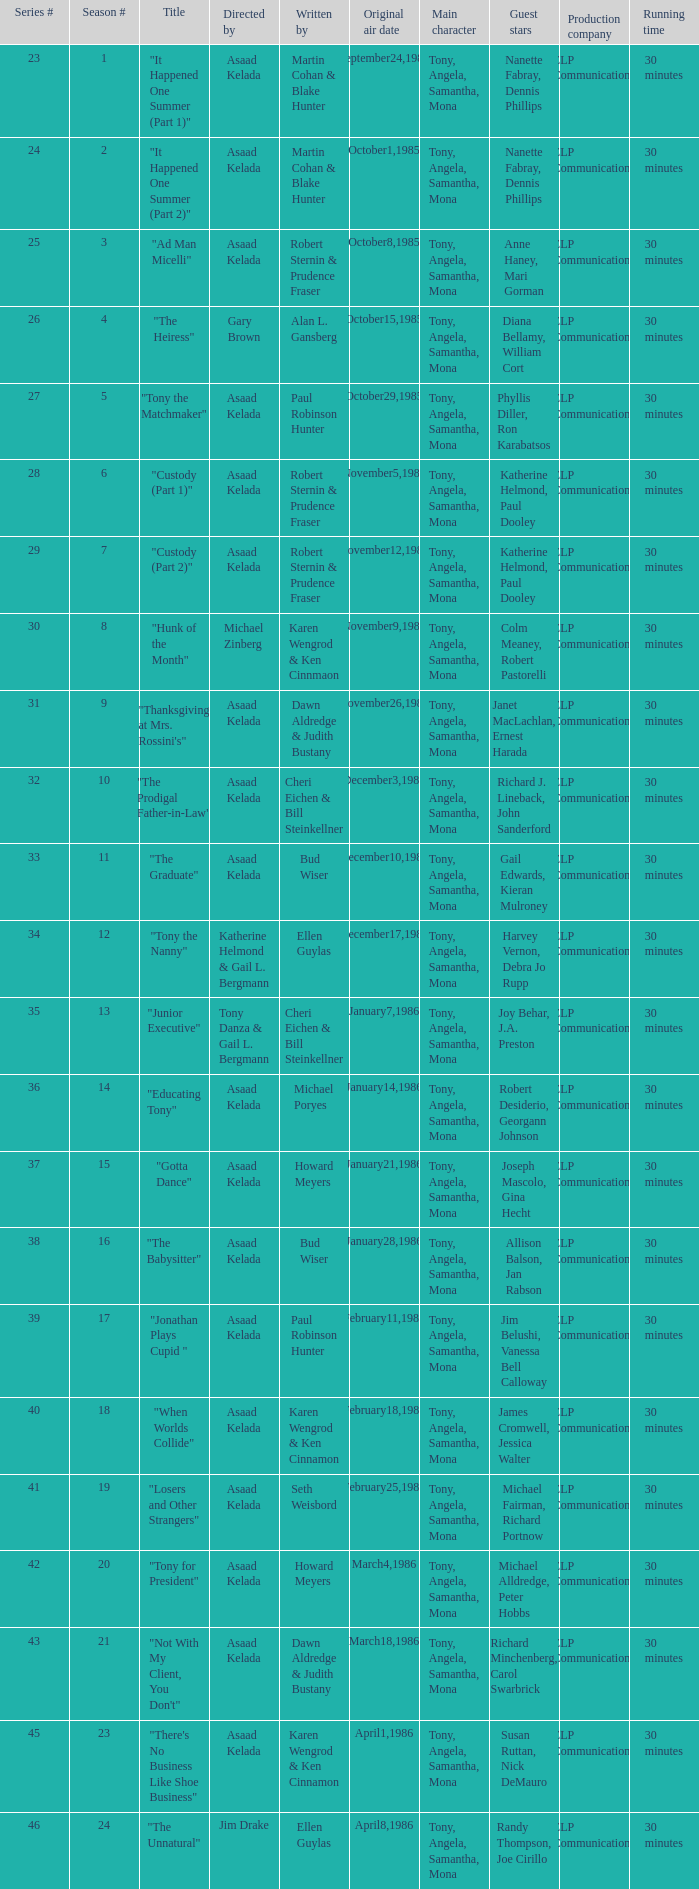Would you mind parsing the complete table? {'header': ['Series #', 'Season #', 'Title', 'Directed by', 'Written by', 'Original air date', 'Main character', 'Guest stars', 'Production company', 'Running time'], 'rows': [['23', '1', '"It Happened One Summer (Part 1)"', 'Asaad Kelada', 'Martin Cohan & Blake Hunter', 'September24,1985', 'Tony, Angela, Samantha, Mona', 'Nanette Fabray, Dennis Phillips', 'ELP Communications', '30 minutes'], ['24', '2', '"It Happened One Summer (Part 2)"', 'Asaad Kelada', 'Martin Cohan & Blake Hunter', 'October1,1985', 'Tony, Angela, Samantha, Mona', 'Nanette Fabray, Dennis Phillips', 'ELP Communications', '30 minutes'], ['25', '3', '"Ad Man Micelli"', 'Asaad Kelada', 'Robert Sternin & Prudence Fraser', 'October8,1985', 'Tony, Angela, Samantha, Mona', 'Anne Haney, Mari Gorman', 'ELP Communications', '30 minutes'], ['26', '4', '"The Heiress"', 'Gary Brown', 'Alan L. Gansberg', 'October15,1985', 'Tony, Angela, Samantha, Mona', 'Diana Bellamy, William Cort', 'ELP Communications', '30 minutes'], ['27', '5', '"Tony the Matchmaker"', 'Asaad Kelada', 'Paul Robinson Hunter', 'October29,1985', 'Tony, Angela, Samantha, Mona', 'Phyllis Diller, Ron Karabatsos', 'ELP Communications', '30 minutes'], ['28', '6', '"Custody (Part 1)"', 'Asaad Kelada', 'Robert Sternin & Prudence Fraser', 'November5,1985', 'Tony, Angela, Samantha, Mona', 'Katherine Helmond, Paul Dooley', 'ELP Communications', '30 minutes'], ['29', '7', '"Custody (Part 2)"', 'Asaad Kelada', 'Robert Sternin & Prudence Fraser', 'November12,1985', 'Tony, Angela, Samantha, Mona', 'Katherine Helmond, Paul Dooley', 'ELP Communications', '30 minutes'], ['30', '8', '"Hunk of the Month"', 'Michael Zinberg', 'Karen Wengrod & Ken Cinnmaon', 'November9,1985', 'Tony, Angela, Samantha, Mona', 'Colm Meaney, Robert Pastorelli', 'ELP Communications', '30 minutes'], ['31', '9', '"Thanksgiving at Mrs. Rossini\'s"', 'Asaad Kelada', 'Dawn Aldredge & Judith Bustany', 'November26,1985', 'Tony, Angela, Samantha, Mona', 'Janet MacLachlan, Ernest Harada', 'ELP Communications', '30 minutes'], ['32', '10', '"The Prodigal Father-in-Law"', 'Asaad Kelada', 'Cheri Eichen & Bill Steinkellner', 'December3,1985', 'Tony, Angela, Samantha, Mona', 'Richard J. Lineback, John Sanderford', 'ELP Communications', '30 minutes'], ['33', '11', '"The Graduate"', 'Asaad Kelada', 'Bud Wiser', 'December10,1985', 'Tony, Angela, Samantha, Mona', 'Gail Edwards, Kieran Mulroney', 'ELP Communications', '30 minutes'], ['34', '12', '"Tony the Nanny"', 'Katherine Helmond & Gail L. Bergmann', 'Ellen Guylas', 'December17,1985', 'Tony, Angela, Samantha, Mona', 'Harvey Vernon, Debra Jo Rupp', 'ELP Communications', '30 minutes'], ['35', '13', '"Junior Executive"', 'Tony Danza & Gail L. Bergmann', 'Cheri Eichen & Bill Steinkellner', 'January7,1986', 'Tony, Angela, Samantha, Mona', 'Joy Behar, J.A. Preston', 'ELP Communications', '30 minutes'], ['36', '14', '"Educating Tony"', 'Asaad Kelada', 'Michael Poryes', 'January14,1986', 'Tony, Angela, Samantha, Mona', 'Robert Desiderio, Georgann Johnson', 'ELP Communications', '30 minutes'], ['37', '15', '"Gotta Dance"', 'Asaad Kelada', 'Howard Meyers', 'January21,1986', 'Tony, Angela, Samantha, Mona', 'Joseph Mascolo, Gina Hecht', 'ELP Communications', '30 minutes'], ['38', '16', '"The Babysitter"', 'Asaad Kelada', 'Bud Wiser', 'January28,1986', 'Tony, Angela, Samantha, Mona', 'Allison Balson, Jan Rabson', 'ELP Communications', '30 minutes'], ['39', '17', '"Jonathan Plays Cupid "', 'Asaad Kelada', 'Paul Robinson Hunter', 'February11,1986', 'Tony, Angela, Samantha, Mona', 'Jim Belushi, Vanessa Bell Calloway', 'ELP Communications', '30 minutes'], ['40', '18', '"When Worlds Collide"', 'Asaad Kelada', 'Karen Wengrod & Ken Cinnamon', 'February18,1986', 'Tony, Angela, Samantha, Mona', 'James Cromwell, Jessica Walter', 'ELP Communications', '30 minutes'], ['41', '19', '"Losers and Other Strangers"', 'Asaad Kelada', 'Seth Weisbord', 'February25,1986', 'Tony, Angela, Samantha, Mona', 'Michael Fairman, Richard Portnow', 'ELP Communications', '30 minutes'], ['42', '20', '"Tony for President"', 'Asaad Kelada', 'Howard Meyers', 'March4,1986', 'Tony, Angela, Samantha, Mona', 'Michael Alldredge, Peter Hobbs', 'ELP Communications', '30 minutes'], ['43', '21', '"Not With My Client, You Don\'t"', 'Asaad Kelada', 'Dawn Aldredge & Judith Bustany', 'March18,1986', 'Tony, Angela, Samantha, Mona', 'Richard Minchenberg, Carol Swarbrick', 'ELP Communications', '30 minutes'], ['45', '23', '"There\'s No Business Like Shoe Business"', 'Asaad Kelada', 'Karen Wengrod & Ken Cinnamon', 'April1,1986', 'Tony, Angela, Samantha, Mona', 'Susan Ruttan, Nick DeMauro', 'ELP Communications', '30 minutes'], ['46', '24', '"The Unnatural"', 'Jim Drake', 'Ellen Guylas', 'April8,1986', 'Tony, Angela, Samantha, Mona', 'Randy Thompson, Joe Cirillo', 'ELP Communications', '30 minutes']]} What is the date of the episode written by Michael Poryes? January14,1986. 